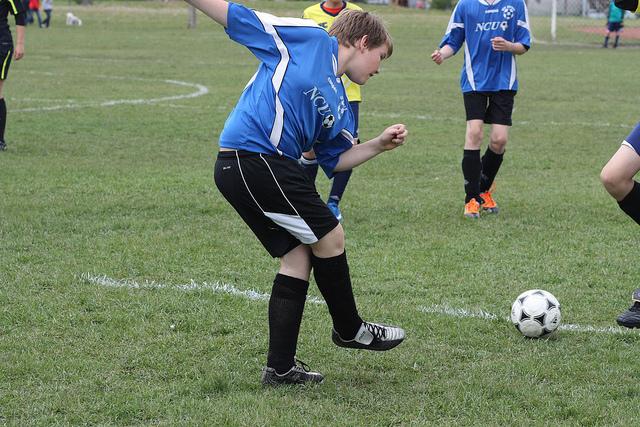How many team members with blue shirts can be seen?
Concise answer only. 2. What sport is this?
Short answer required. Soccer. How many team members with the yellow shirts can be seen?
Keep it brief. 1. How many balls are there?
Be succinct. 1. What color is the ball?
Concise answer only. White and black. Is there a pink chair shown?
Be succinct. No. 